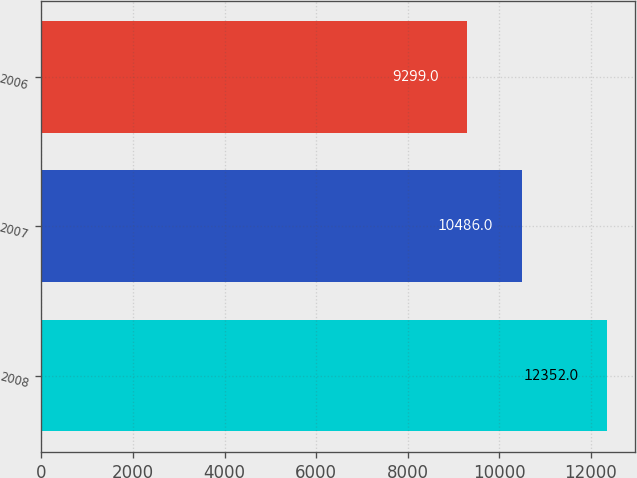<chart> <loc_0><loc_0><loc_500><loc_500><bar_chart><fcel>2008<fcel>2007<fcel>2006<nl><fcel>12352<fcel>10486<fcel>9299<nl></chart> 